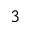<formula> <loc_0><loc_0><loc_500><loc_500>_ { 3 }</formula> 